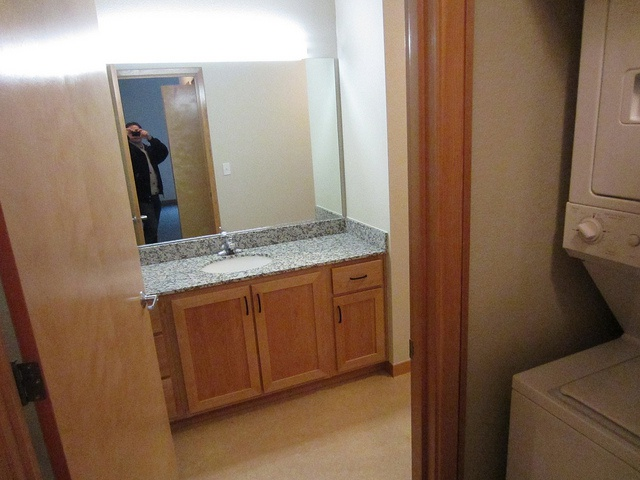Describe the objects in this image and their specific colors. I can see people in tan, black, and gray tones and sink in tan, lightgray, darkgray, and gray tones in this image. 